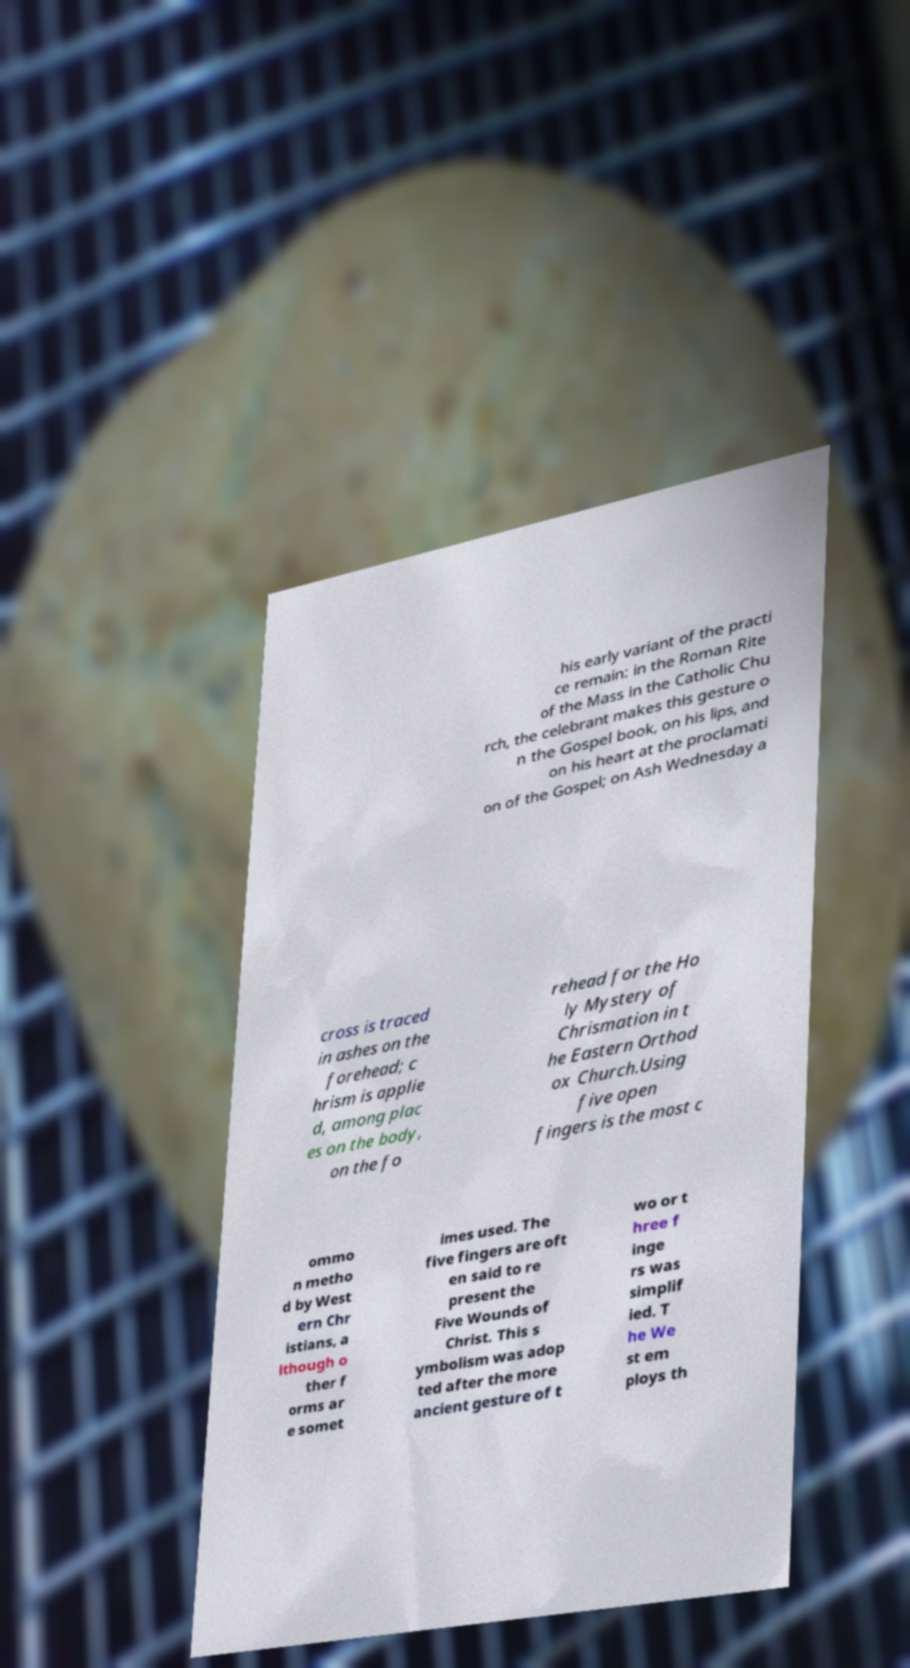Please identify and transcribe the text found in this image. his early variant of the practi ce remain: in the Roman Rite of the Mass in the Catholic Chu rch, the celebrant makes this gesture o n the Gospel book, on his lips, and on his heart at the proclamati on of the Gospel; on Ash Wednesday a cross is traced in ashes on the forehead; c hrism is applie d, among plac es on the body, on the fo rehead for the Ho ly Mystery of Chrismation in t he Eastern Orthod ox Church.Using five open fingers is the most c ommo n metho d by West ern Chr istians, a lthough o ther f orms ar e somet imes used. The five fingers are oft en said to re present the Five Wounds of Christ. This s ymbolism was adop ted after the more ancient gesture of t wo or t hree f inge rs was simplif ied. T he We st em ploys th 